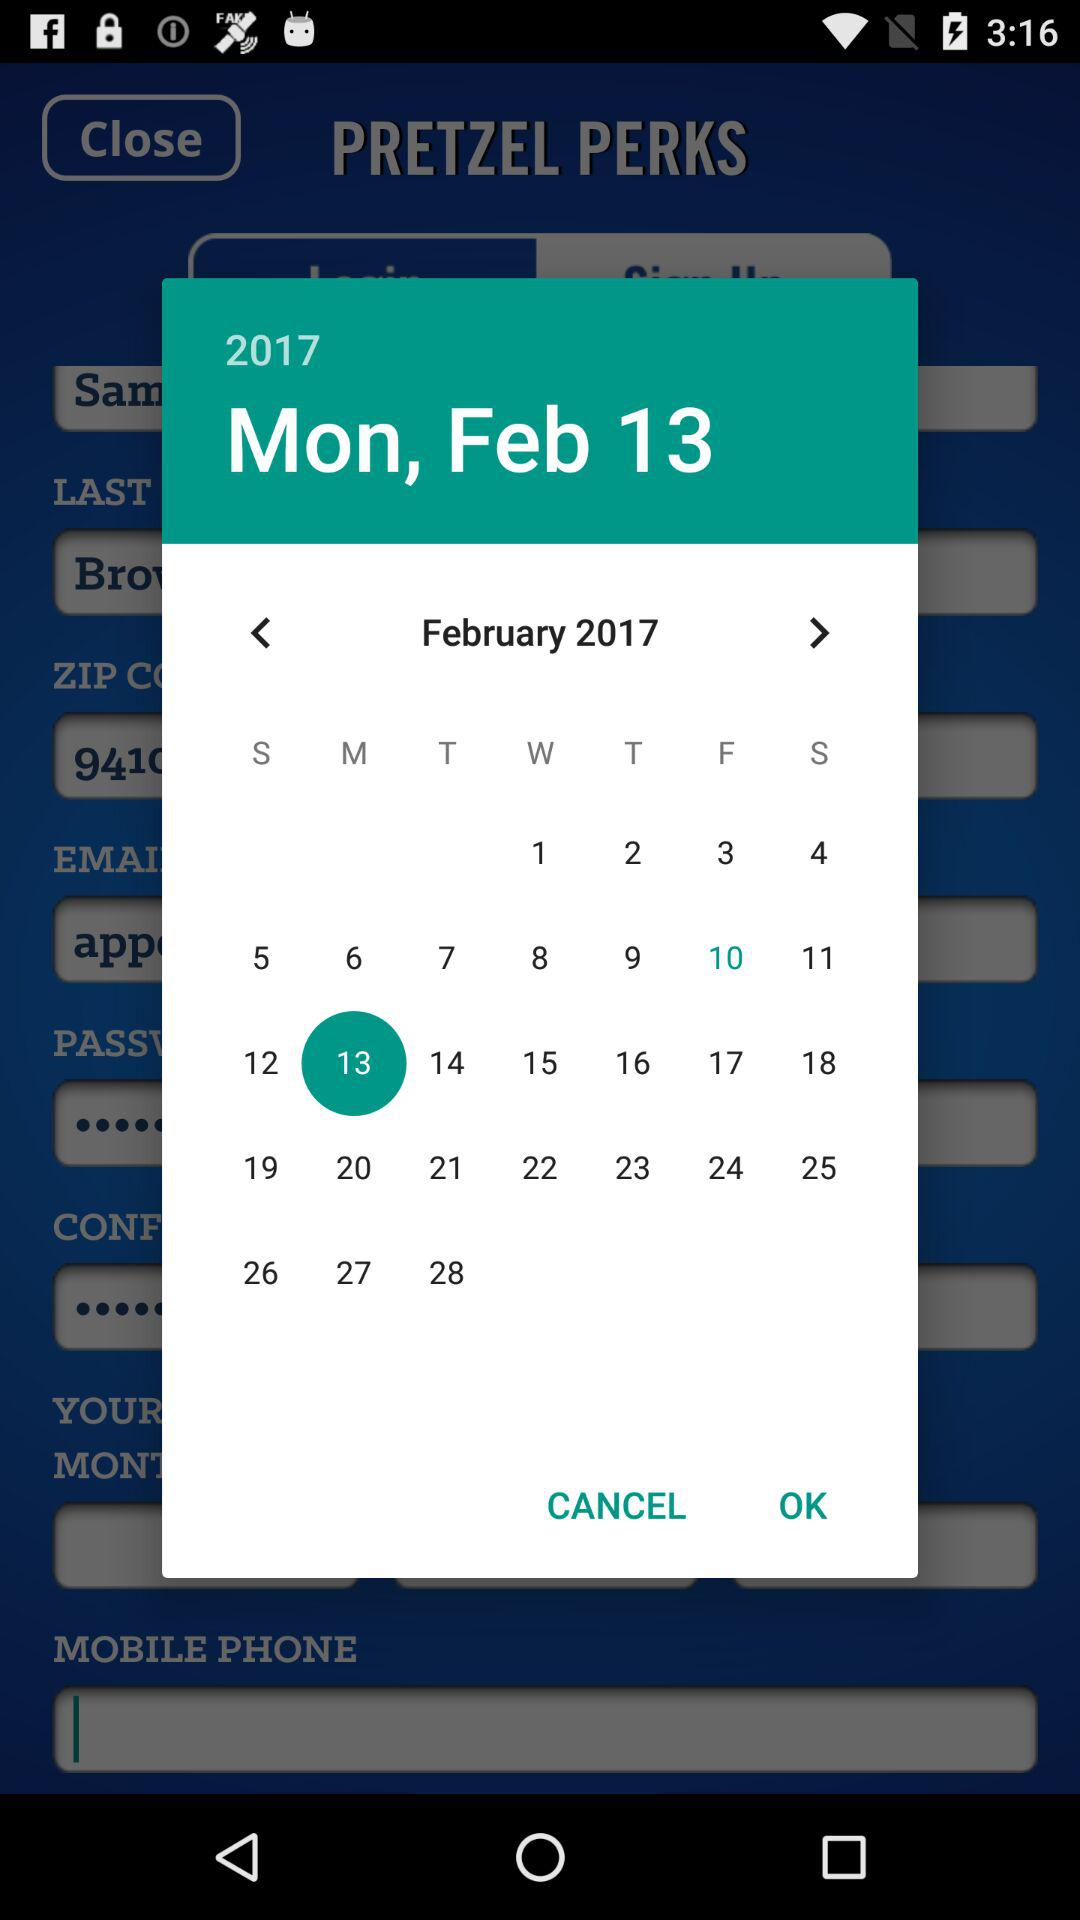Which date is selected? The selected date is Monday, February 13, 2017. 